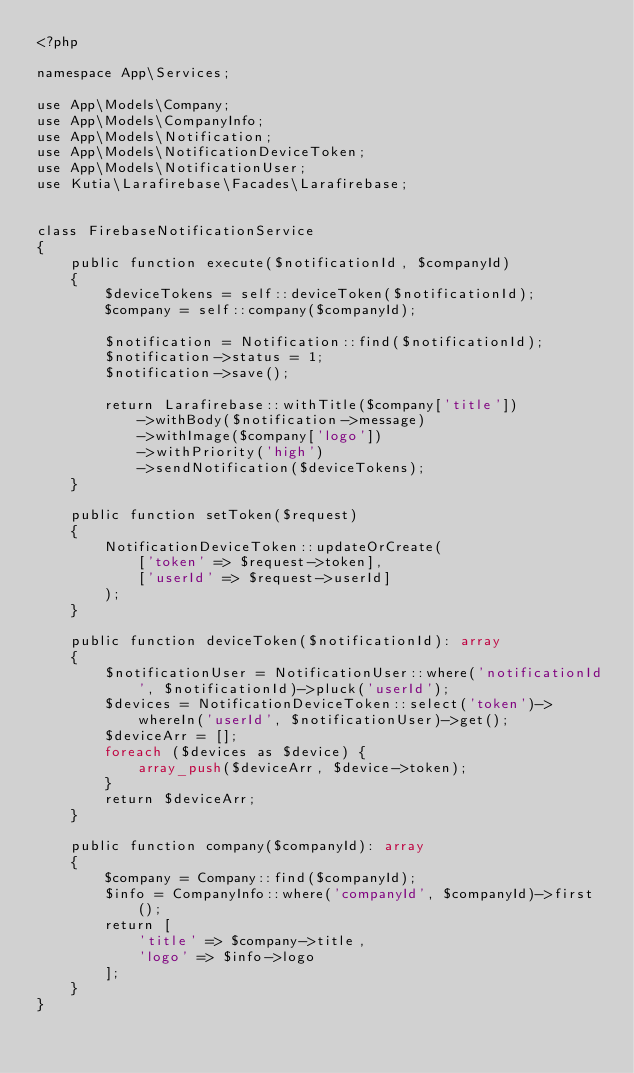<code> <loc_0><loc_0><loc_500><loc_500><_PHP_><?php

namespace App\Services;

use App\Models\Company;
use App\Models\CompanyInfo;
use App\Models\Notification;
use App\Models\NotificationDeviceToken;
use App\Models\NotificationUser;
use Kutia\Larafirebase\Facades\Larafirebase;


class FirebaseNotificationService
{
    public function execute($notificationId, $companyId)
    {
        $deviceTokens = self::deviceToken($notificationId);
        $company = self::company($companyId);

        $notification = Notification::find($notificationId);
        $notification->status = 1;
        $notification->save();

        return Larafirebase::withTitle($company['title'])
            ->withBody($notification->message)
            ->withImage($company['logo'])
            ->withPriority('high')
            ->sendNotification($deviceTokens);
    }

    public function setToken($request)
    {
        NotificationDeviceToken::updateOrCreate(
            ['token' => $request->token],
            ['userId' => $request->userId]
        );
    }

    public function deviceToken($notificationId): array
    {
        $notificationUser = NotificationUser::where('notificationId', $notificationId)->pluck('userId');
        $devices = NotificationDeviceToken::select('token')->whereIn('userId', $notificationUser)->get();
        $deviceArr = [];
        foreach ($devices as $device) {
            array_push($deviceArr, $device->token);
        }
        return $deviceArr;
    }

    public function company($companyId): array
    {
        $company = Company::find($companyId);
        $info = CompanyInfo::where('companyId', $companyId)->first();
        return [
            'title' => $company->title,
            'logo' => $info->logo
        ];
    }
}
</code> 